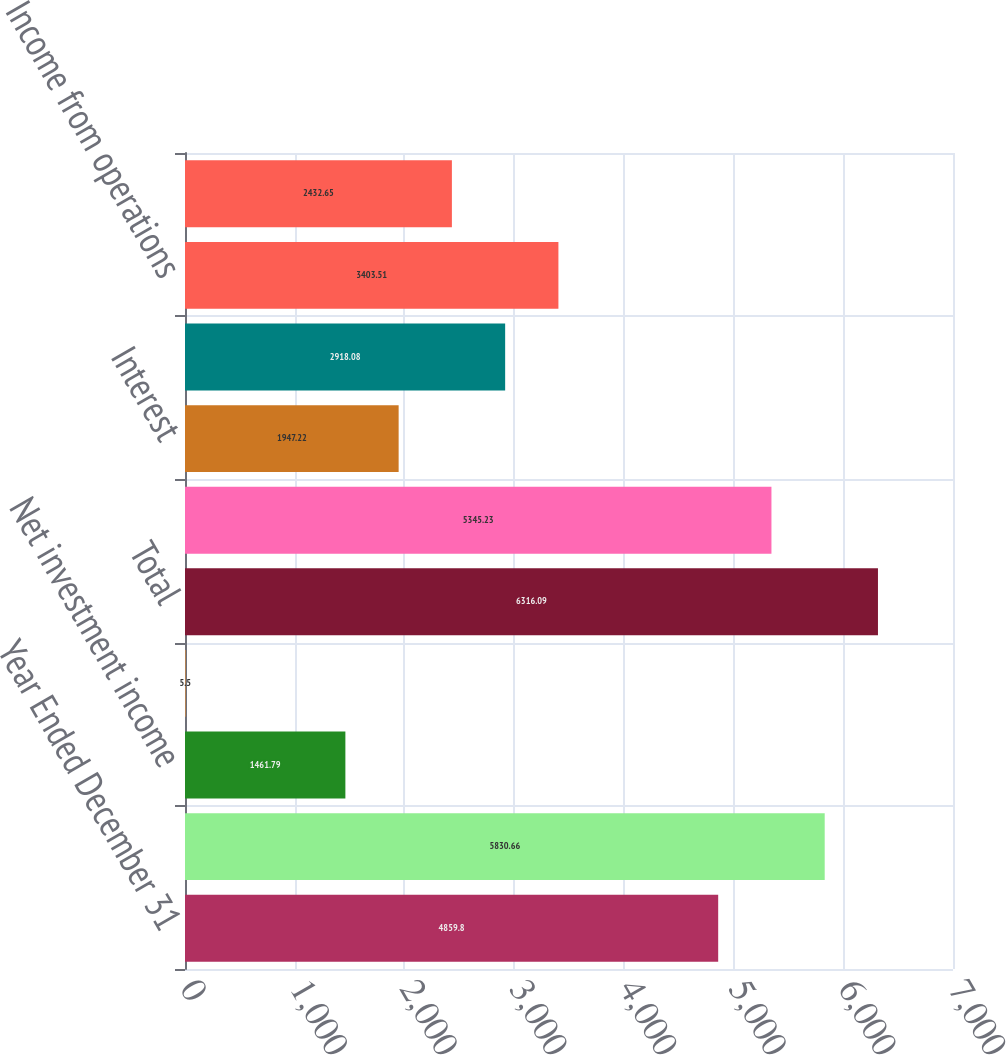Convert chart. <chart><loc_0><loc_0><loc_500><loc_500><bar_chart><fcel>Year Ended December 31<fcel>Manufactured products and<fcel>Net investment income<fcel>Investment losses<fcel>Total<fcel>Cost of manufactured products<fcel>Interest<fcel>Income tax expense<fcel>Income from operations<fcel>CNA<nl><fcel>4859.8<fcel>5830.66<fcel>1461.79<fcel>5.5<fcel>6316.09<fcel>5345.23<fcel>1947.22<fcel>2918.08<fcel>3403.51<fcel>2432.65<nl></chart> 